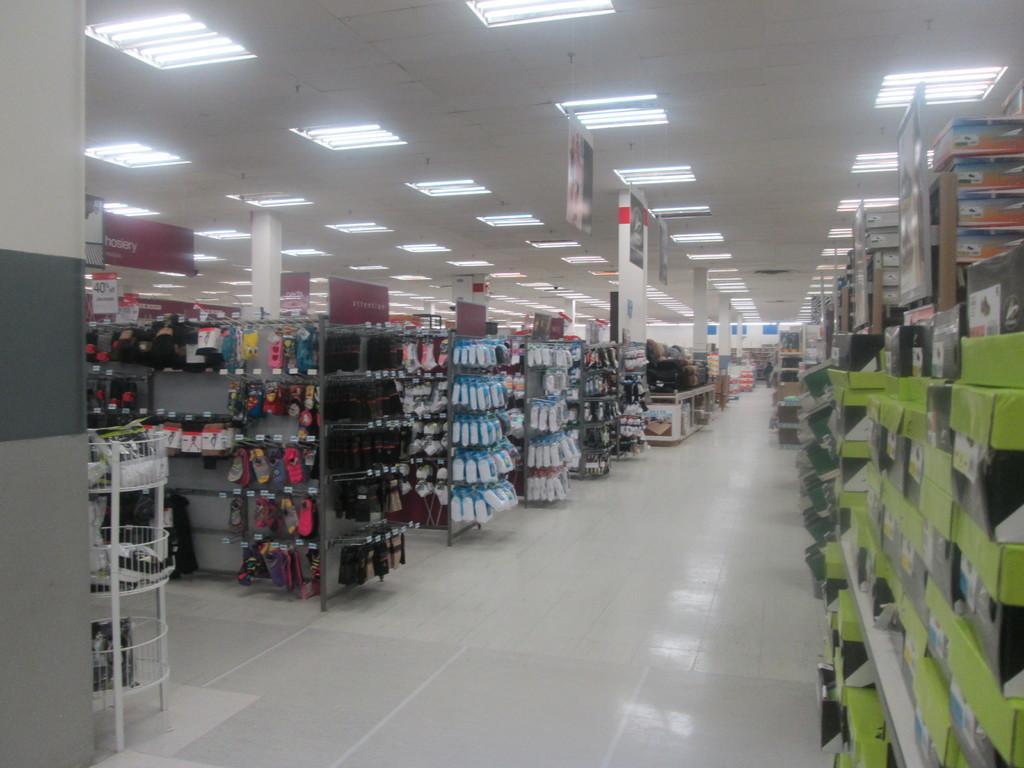How would you summarize this image in a sentence or two? In this image I see the floor, number of racks on which there are colorful things and I see number of boxes over here and in the background I see the lights on the ceiling and I see the wall over here. 